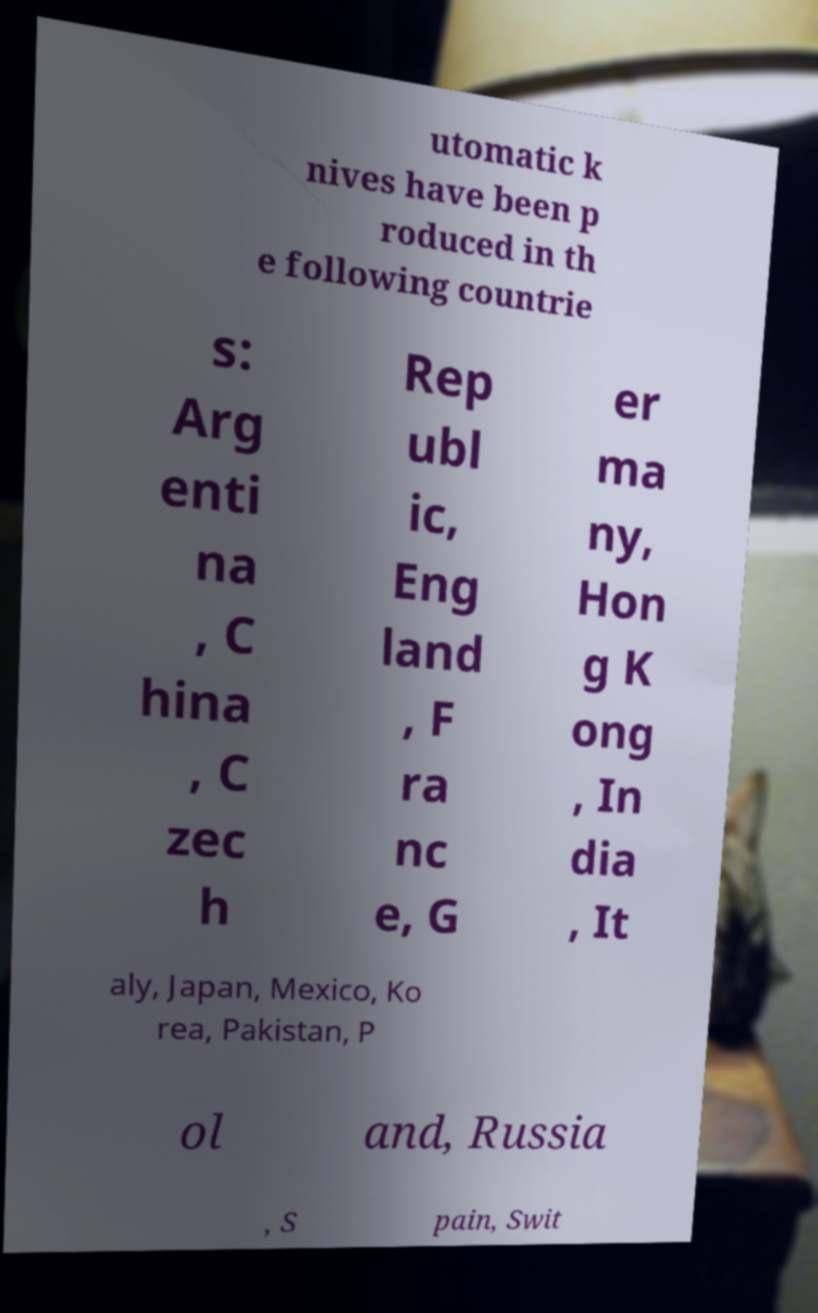Can you read and provide the text displayed in the image?This photo seems to have some interesting text. Can you extract and type it out for me? utomatic k nives have been p roduced in th e following countrie s: Arg enti na , C hina , C zec h Rep ubl ic, Eng land , F ra nc e, G er ma ny, Hon g K ong , In dia , It aly, Japan, Mexico, Ko rea, Pakistan, P ol and, Russia , S pain, Swit 